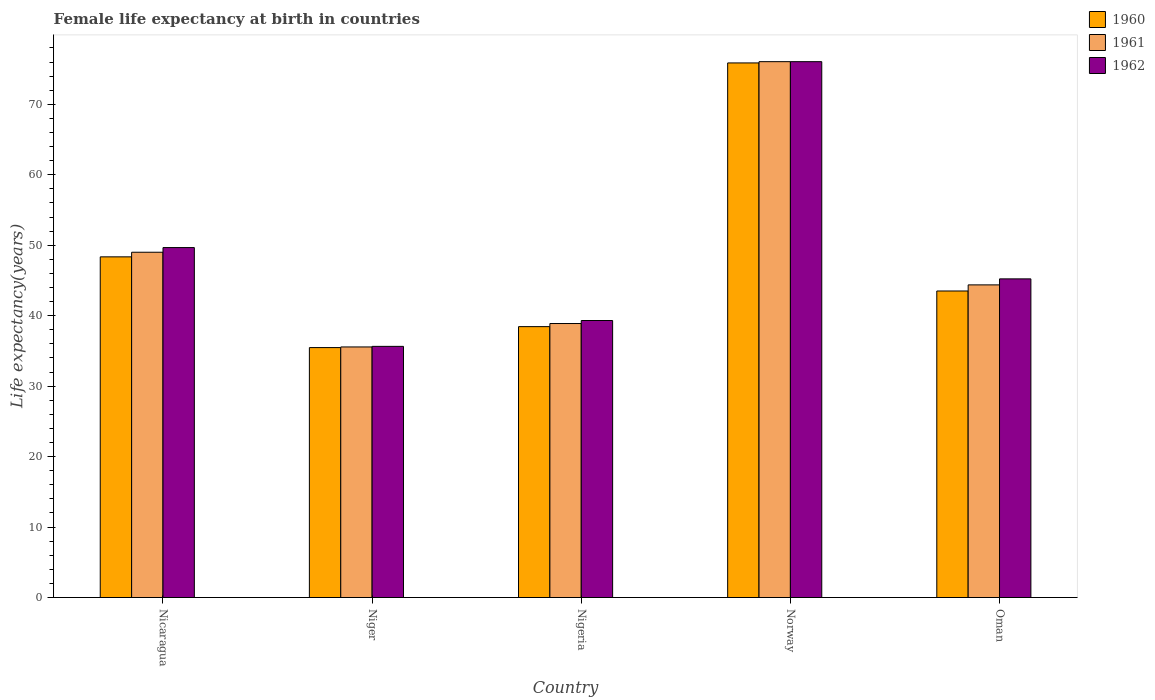How many different coloured bars are there?
Provide a short and direct response. 3. Are the number of bars per tick equal to the number of legend labels?
Give a very brief answer. Yes. Are the number of bars on each tick of the X-axis equal?
Offer a very short reply. Yes. How many bars are there on the 4th tick from the left?
Offer a very short reply. 3. How many bars are there on the 3rd tick from the right?
Ensure brevity in your answer.  3. What is the label of the 4th group of bars from the left?
Offer a terse response. Norway. What is the female life expectancy at birth in 1961 in Oman?
Keep it short and to the point. 44.37. Across all countries, what is the maximum female life expectancy at birth in 1961?
Make the answer very short. 76.05. Across all countries, what is the minimum female life expectancy at birth in 1962?
Offer a terse response. 35.65. In which country was the female life expectancy at birth in 1962 minimum?
Provide a succinct answer. Niger. What is the total female life expectancy at birth in 1961 in the graph?
Your response must be concise. 243.88. What is the difference between the female life expectancy at birth in 1962 in Niger and that in Nigeria?
Your answer should be compact. -3.67. What is the difference between the female life expectancy at birth in 1962 in Norway and the female life expectancy at birth in 1961 in Oman?
Provide a succinct answer. 31.68. What is the average female life expectancy at birth in 1962 per country?
Keep it short and to the point. 49.18. What is the difference between the female life expectancy at birth of/in 1960 and female life expectancy at birth of/in 1962 in Oman?
Make the answer very short. -1.72. In how many countries, is the female life expectancy at birth in 1960 greater than 38 years?
Your answer should be compact. 4. What is the ratio of the female life expectancy at birth in 1961 in Nicaragua to that in Niger?
Provide a short and direct response. 1.38. Is the female life expectancy at birth in 1961 in Niger less than that in Norway?
Give a very brief answer. Yes. Is the difference between the female life expectancy at birth in 1960 in Nicaragua and Nigeria greater than the difference between the female life expectancy at birth in 1962 in Nicaragua and Nigeria?
Give a very brief answer. No. What is the difference between the highest and the second highest female life expectancy at birth in 1960?
Your answer should be compact. 4.85. What is the difference between the highest and the lowest female life expectancy at birth in 1962?
Keep it short and to the point. 40.4. How many bars are there?
Keep it short and to the point. 15. What is the difference between two consecutive major ticks on the Y-axis?
Make the answer very short. 10. Does the graph contain grids?
Your answer should be very brief. No. Where does the legend appear in the graph?
Keep it short and to the point. Top right. How many legend labels are there?
Offer a terse response. 3. What is the title of the graph?
Ensure brevity in your answer.  Female life expectancy at birth in countries. What is the label or title of the Y-axis?
Ensure brevity in your answer.  Life expectancy(years). What is the Life expectancy(years) of 1960 in Nicaragua?
Keep it short and to the point. 48.35. What is the Life expectancy(years) in 1961 in Nicaragua?
Your answer should be very brief. 49. What is the Life expectancy(years) of 1962 in Nicaragua?
Offer a terse response. 49.67. What is the Life expectancy(years) of 1960 in Niger?
Offer a terse response. 35.47. What is the Life expectancy(years) in 1961 in Niger?
Your answer should be very brief. 35.56. What is the Life expectancy(years) in 1962 in Niger?
Ensure brevity in your answer.  35.65. What is the Life expectancy(years) in 1960 in Nigeria?
Your answer should be very brief. 38.45. What is the Life expectancy(years) of 1961 in Nigeria?
Provide a short and direct response. 38.89. What is the Life expectancy(years) of 1962 in Nigeria?
Your answer should be very brief. 39.31. What is the Life expectancy(years) of 1960 in Norway?
Provide a succinct answer. 75.87. What is the Life expectancy(years) of 1961 in Norway?
Offer a very short reply. 76.05. What is the Life expectancy(years) of 1962 in Norway?
Offer a terse response. 76.05. What is the Life expectancy(years) of 1960 in Oman?
Your answer should be compact. 43.5. What is the Life expectancy(years) of 1961 in Oman?
Your response must be concise. 44.37. What is the Life expectancy(years) in 1962 in Oman?
Offer a terse response. 45.22. Across all countries, what is the maximum Life expectancy(years) in 1960?
Give a very brief answer. 75.87. Across all countries, what is the maximum Life expectancy(years) of 1961?
Your answer should be very brief. 76.05. Across all countries, what is the maximum Life expectancy(years) in 1962?
Ensure brevity in your answer.  76.05. Across all countries, what is the minimum Life expectancy(years) in 1960?
Your answer should be compact. 35.47. Across all countries, what is the minimum Life expectancy(years) of 1961?
Ensure brevity in your answer.  35.56. Across all countries, what is the minimum Life expectancy(years) of 1962?
Offer a very short reply. 35.65. What is the total Life expectancy(years) in 1960 in the graph?
Offer a very short reply. 241.64. What is the total Life expectancy(years) of 1961 in the graph?
Offer a terse response. 243.88. What is the total Life expectancy(years) of 1962 in the graph?
Keep it short and to the point. 245.9. What is the difference between the Life expectancy(years) of 1960 in Nicaragua and that in Niger?
Your response must be concise. 12.88. What is the difference between the Life expectancy(years) in 1961 in Nicaragua and that in Niger?
Offer a terse response. 13.44. What is the difference between the Life expectancy(years) in 1962 in Nicaragua and that in Niger?
Your answer should be very brief. 14.02. What is the difference between the Life expectancy(years) in 1960 in Nicaragua and that in Nigeria?
Offer a very short reply. 9.9. What is the difference between the Life expectancy(years) of 1961 in Nicaragua and that in Nigeria?
Ensure brevity in your answer.  10.12. What is the difference between the Life expectancy(years) of 1962 in Nicaragua and that in Nigeria?
Make the answer very short. 10.35. What is the difference between the Life expectancy(years) of 1960 in Nicaragua and that in Norway?
Your answer should be compact. -27.52. What is the difference between the Life expectancy(years) in 1961 in Nicaragua and that in Norway?
Your answer should be compact. -27.05. What is the difference between the Life expectancy(years) in 1962 in Nicaragua and that in Norway?
Provide a short and direct response. -26.38. What is the difference between the Life expectancy(years) of 1960 in Nicaragua and that in Oman?
Your answer should be compact. 4.85. What is the difference between the Life expectancy(years) of 1961 in Nicaragua and that in Oman?
Your response must be concise. 4.63. What is the difference between the Life expectancy(years) of 1962 in Nicaragua and that in Oman?
Your answer should be compact. 4.44. What is the difference between the Life expectancy(years) in 1960 in Niger and that in Nigeria?
Offer a very short reply. -2.97. What is the difference between the Life expectancy(years) of 1961 in Niger and that in Nigeria?
Provide a short and direct response. -3.33. What is the difference between the Life expectancy(years) of 1962 in Niger and that in Nigeria?
Give a very brief answer. -3.67. What is the difference between the Life expectancy(years) of 1960 in Niger and that in Norway?
Keep it short and to the point. -40.4. What is the difference between the Life expectancy(years) of 1961 in Niger and that in Norway?
Give a very brief answer. -40.49. What is the difference between the Life expectancy(years) in 1962 in Niger and that in Norway?
Offer a terse response. -40.4. What is the difference between the Life expectancy(years) in 1960 in Niger and that in Oman?
Your response must be concise. -8.03. What is the difference between the Life expectancy(years) of 1961 in Niger and that in Oman?
Your response must be concise. -8.81. What is the difference between the Life expectancy(years) of 1962 in Niger and that in Oman?
Provide a short and direct response. -9.58. What is the difference between the Life expectancy(years) in 1960 in Nigeria and that in Norway?
Give a very brief answer. -37.42. What is the difference between the Life expectancy(years) of 1961 in Nigeria and that in Norway?
Give a very brief answer. -37.16. What is the difference between the Life expectancy(years) in 1962 in Nigeria and that in Norway?
Keep it short and to the point. -36.73. What is the difference between the Life expectancy(years) of 1960 in Nigeria and that in Oman?
Your response must be concise. -5.06. What is the difference between the Life expectancy(years) in 1961 in Nigeria and that in Oman?
Provide a short and direct response. -5.49. What is the difference between the Life expectancy(years) in 1962 in Nigeria and that in Oman?
Give a very brief answer. -5.91. What is the difference between the Life expectancy(years) of 1960 in Norway and that in Oman?
Provide a succinct answer. 32.37. What is the difference between the Life expectancy(years) of 1961 in Norway and that in Oman?
Offer a terse response. 31.68. What is the difference between the Life expectancy(years) of 1962 in Norway and that in Oman?
Your response must be concise. 30.83. What is the difference between the Life expectancy(years) in 1960 in Nicaragua and the Life expectancy(years) in 1961 in Niger?
Keep it short and to the point. 12.79. What is the difference between the Life expectancy(years) of 1960 in Nicaragua and the Life expectancy(years) of 1962 in Niger?
Make the answer very short. 12.7. What is the difference between the Life expectancy(years) of 1961 in Nicaragua and the Life expectancy(years) of 1962 in Niger?
Keep it short and to the point. 13.36. What is the difference between the Life expectancy(years) in 1960 in Nicaragua and the Life expectancy(years) in 1961 in Nigeria?
Your response must be concise. 9.46. What is the difference between the Life expectancy(years) of 1960 in Nicaragua and the Life expectancy(years) of 1962 in Nigeria?
Offer a very short reply. 9.04. What is the difference between the Life expectancy(years) of 1961 in Nicaragua and the Life expectancy(years) of 1962 in Nigeria?
Give a very brief answer. 9.69. What is the difference between the Life expectancy(years) of 1960 in Nicaragua and the Life expectancy(years) of 1961 in Norway?
Make the answer very short. -27.7. What is the difference between the Life expectancy(years) in 1960 in Nicaragua and the Life expectancy(years) in 1962 in Norway?
Your answer should be compact. -27.7. What is the difference between the Life expectancy(years) in 1961 in Nicaragua and the Life expectancy(years) in 1962 in Norway?
Make the answer very short. -27.05. What is the difference between the Life expectancy(years) in 1960 in Nicaragua and the Life expectancy(years) in 1961 in Oman?
Offer a terse response. 3.98. What is the difference between the Life expectancy(years) of 1960 in Nicaragua and the Life expectancy(years) of 1962 in Oman?
Give a very brief answer. 3.13. What is the difference between the Life expectancy(years) in 1961 in Nicaragua and the Life expectancy(years) in 1962 in Oman?
Your answer should be compact. 3.78. What is the difference between the Life expectancy(years) in 1960 in Niger and the Life expectancy(years) in 1961 in Nigeria?
Your response must be concise. -3.42. What is the difference between the Life expectancy(years) in 1960 in Niger and the Life expectancy(years) in 1962 in Nigeria?
Your answer should be compact. -3.84. What is the difference between the Life expectancy(years) in 1961 in Niger and the Life expectancy(years) in 1962 in Nigeria?
Ensure brevity in your answer.  -3.75. What is the difference between the Life expectancy(years) in 1960 in Niger and the Life expectancy(years) in 1961 in Norway?
Give a very brief answer. -40.58. What is the difference between the Life expectancy(years) in 1960 in Niger and the Life expectancy(years) in 1962 in Norway?
Your answer should be compact. -40.58. What is the difference between the Life expectancy(years) in 1961 in Niger and the Life expectancy(years) in 1962 in Norway?
Your response must be concise. -40.49. What is the difference between the Life expectancy(years) of 1960 in Niger and the Life expectancy(years) of 1961 in Oman?
Give a very brief answer. -8.9. What is the difference between the Life expectancy(years) of 1960 in Niger and the Life expectancy(years) of 1962 in Oman?
Offer a very short reply. -9.75. What is the difference between the Life expectancy(years) in 1961 in Niger and the Life expectancy(years) in 1962 in Oman?
Offer a very short reply. -9.66. What is the difference between the Life expectancy(years) in 1960 in Nigeria and the Life expectancy(years) in 1961 in Norway?
Your answer should be very brief. -37.6. What is the difference between the Life expectancy(years) of 1960 in Nigeria and the Life expectancy(years) of 1962 in Norway?
Offer a terse response. -37.6. What is the difference between the Life expectancy(years) of 1961 in Nigeria and the Life expectancy(years) of 1962 in Norway?
Keep it short and to the point. -37.16. What is the difference between the Life expectancy(years) of 1960 in Nigeria and the Life expectancy(years) of 1961 in Oman?
Your response must be concise. -5.93. What is the difference between the Life expectancy(years) of 1960 in Nigeria and the Life expectancy(years) of 1962 in Oman?
Provide a short and direct response. -6.78. What is the difference between the Life expectancy(years) of 1961 in Nigeria and the Life expectancy(years) of 1962 in Oman?
Provide a succinct answer. -6.34. What is the difference between the Life expectancy(years) of 1960 in Norway and the Life expectancy(years) of 1961 in Oman?
Give a very brief answer. 31.5. What is the difference between the Life expectancy(years) in 1960 in Norway and the Life expectancy(years) in 1962 in Oman?
Offer a terse response. 30.65. What is the difference between the Life expectancy(years) in 1961 in Norway and the Life expectancy(years) in 1962 in Oman?
Your response must be concise. 30.83. What is the average Life expectancy(years) of 1960 per country?
Your response must be concise. 48.33. What is the average Life expectancy(years) of 1961 per country?
Ensure brevity in your answer.  48.77. What is the average Life expectancy(years) in 1962 per country?
Give a very brief answer. 49.18. What is the difference between the Life expectancy(years) of 1960 and Life expectancy(years) of 1961 in Nicaragua?
Offer a terse response. -0.65. What is the difference between the Life expectancy(years) of 1960 and Life expectancy(years) of 1962 in Nicaragua?
Provide a succinct answer. -1.32. What is the difference between the Life expectancy(years) of 1961 and Life expectancy(years) of 1962 in Nicaragua?
Your answer should be compact. -0.66. What is the difference between the Life expectancy(years) of 1960 and Life expectancy(years) of 1961 in Niger?
Your response must be concise. -0.09. What is the difference between the Life expectancy(years) of 1960 and Life expectancy(years) of 1962 in Niger?
Your answer should be very brief. -0.17. What is the difference between the Life expectancy(years) in 1961 and Life expectancy(years) in 1962 in Niger?
Keep it short and to the point. -0.08. What is the difference between the Life expectancy(years) in 1960 and Life expectancy(years) in 1961 in Nigeria?
Offer a very short reply. -0.44. What is the difference between the Life expectancy(years) of 1960 and Life expectancy(years) of 1962 in Nigeria?
Ensure brevity in your answer.  -0.87. What is the difference between the Life expectancy(years) of 1961 and Life expectancy(years) of 1962 in Nigeria?
Provide a short and direct response. -0.43. What is the difference between the Life expectancy(years) in 1960 and Life expectancy(years) in 1961 in Norway?
Offer a terse response. -0.18. What is the difference between the Life expectancy(years) in 1960 and Life expectancy(years) in 1962 in Norway?
Your response must be concise. -0.18. What is the difference between the Life expectancy(years) of 1960 and Life expectancy(years) of 1961 in Oman?
Your answer should be very brief. -0.87. What is the difference between the Life expectancy(years) of 1960 and Life expectancy(years) of 1962 in Oman?
Make the answer very short. -1.72. What is the difference between the Life expectancy(years) of 1961 and Life expectancy(years) of 1962 in Oman?
Offer a very short reply. -0.85. What is the ratio of the Life expectancy(years) of 1960 in Nicaragua to that in Niger?
Provide a succinct answer. 1.36. What is the ratio of the Life expectancy(years) of 1961 in Nicaragua to that in Niger?
Your response must be concise. 1.38. What is the ratio of the Life expectancy(years) of 1962 in Nicaragua to that in Niger?
Give a very brief answer. 1.39. What is the ratio of the Life expectancy(years) in 1960 in Nicaragua to that in Nigeria?
Your response must be concise. 1.26. What is the ratio of the Life expectancy(years) in 1961 in Nicaragua to that in Nigeria?
Keep it short and to the point. 1.26. What is the ratio of the Life expectancy(years) in 1962 in Nicaragua to that in Nigeria?
Provide a succinct answer. 1.26. What is the ratio of the Life expectancy(years) in 1960 in Nicaragua to that in Norway?
Keep it short and to the point. 0.64. What is the ratio of the Life expectancy(years) of 1961 in Nicaragua to that in Norway?
Your answer should be compact. 0.64. What is the ratio of the Life expectancy(years) in 1962 in Nicaragua to that in Norway?
Ensure brevity in your answer.  0.65. What is the ratio of the Life expectancy(years) of 1960 in Nicaragua to that in Oman?
Your answer should be very brief. 1.11. What is the ratio of the Life expectancy(years) of 1961 in Nicaragua to that in Oman?
Give a very brief answer. 1.1. What is the ratio of the Life expectancy(years) of 1962 in Nicaragua to that in Oman?
Your answer should be compact. 1.1. What is the ratio of the Life expectancy(years) in 1960 in Niger to that in Nigeria?
Offer a very short reply. 0.92. What is the ratio of the Life expectancy(years) in 1961 in Niger to that in Nigeria?
Keep it short and to the point. 0.91. What is the ratio of the Life expectancy(years) of 1962 in Niger to that in Nigeria?
Your answer should be very brief. 0.91. What is the ratio of the Life expectancy(years) in 1960 in Niger to that in Norway?
Provide a short and direct response. 0.47. What is the ratio of the Life expectancy(years) in 1961 in Niger to that in Norway?
Give a very brief answer. 0.47. What is the ratio of the Life expectancy(years) in 1962 in Niger to that in Norway?
Your response must be concise. 0.47. What is the ratio of the Life expectancy(years) of 1960 in Niger to that in Oman?
Your answer should be compact. 0.82. What is the ratio of the Life expectancy(years) of 1961 in Niger to that in Oman?
Ensure brevity in your answer.  0.8. What is the ratio of the Life expectancy(years) in 1962 in Niger to that in Oman?
Give a very brief answer. 0.79. What is the ratio of the Life expectancy(years) of 1960 in Nigeria to that in Norway?
Your response must be concise. 0.51. What is the ratio of the Life expectancy(years) of 1961 in Nigeria to that in Norway?
Ensure brevity in your answer.  0.51. What is the ratio of the Life expectancy(years) of 1962 in Nigeria to that in Norway?
Offer a terse response. 0.52. What is the ratio of the Life expectancy(years) of 1960 in Nigeria to that in Oman?
Give a very brief answer. 0.88. What is the ratio of the Life expectancy(years) in 1961 in Nigeria to that in Oman?
Offer a very short reply. 0.88. What is the ratio of the Life expectancy(years) of 1962 in Nigeria to that in Oman?
Provide a succinct answer. 0.87. What is the ratio of the Life expectancy(years) of 1960 in Norway to that in Oman?
Keep it short and to the point. 1.74. What is the ratio of the Life expectancy(years) in 1961 in Norway to that in Oman?
Make the answer very short. 1.71. What is the ratio of the Life expectancy(years) in 1962 in Norway to that in Oman?
Give a very brief answer. 1.68. What is the difference between the highest and the second highest Life expectancy(years) of 1960?
Your response must be concise. 27.52. What is the difference between the highest and the second highest Life expectancy(years) of 1961?
Give a very brief answer. 27.05. What is the difference between the highest and the second highest Life expectancy(years) in 1962?
Offer a terse response. 26.38. What is the difference between the highest and the lowest Life expectancy(years) in 1960?
Your answer should be very brief. 40.4. What is the difference between the highest and the lowest Life expectancy(years) of 1961?
Provide a succinct answer. 40.49. What is the difference between the highest and the lowest Life expectancy(years) of 1962?
Make the answer very short. 40.4. 